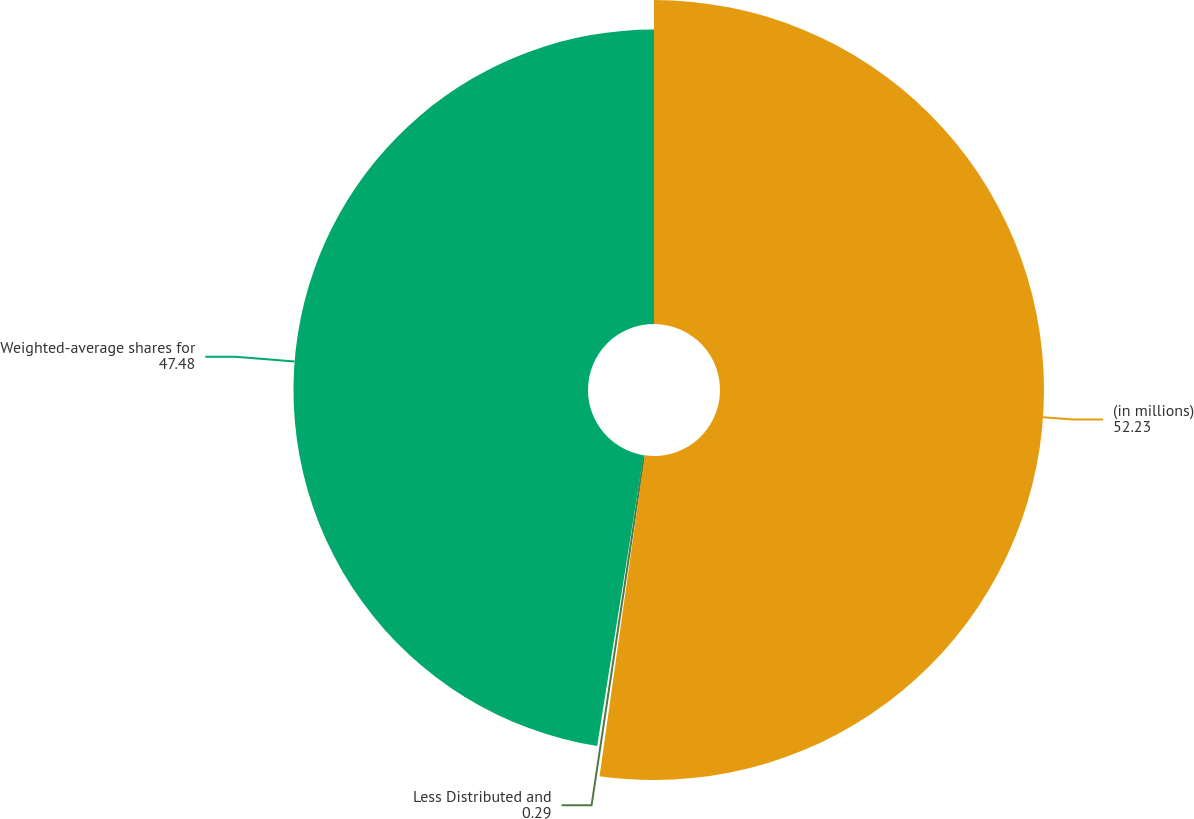Convert chart to OTSL. <chart><loc_0><loc_0><loc_500><loc_500><pie_chart><fcel>(in millions)<fcel>Less Distributed and<fcel>Weighted-average shares for<nl><fcel>52.23%<fcel>0.29%<fcel>47.48%<nl></chart> 